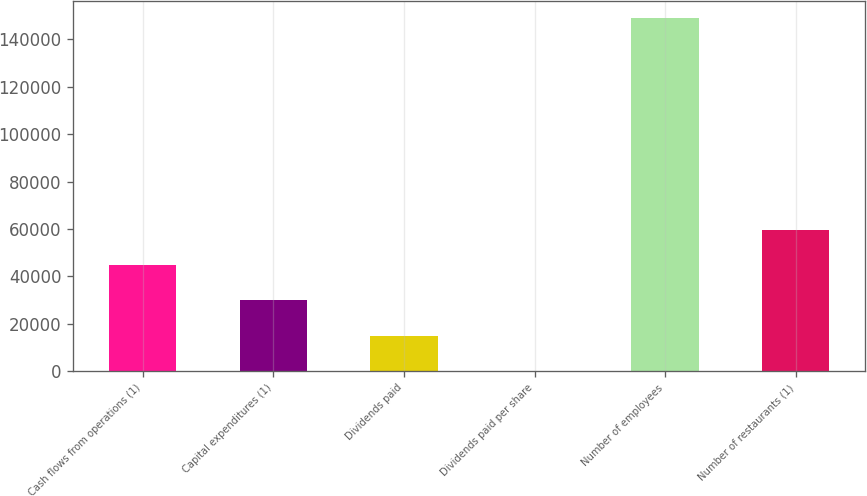Convert chart to OTSL. <chart><loc_0><loc_0><loc_500><loc_500><bar_chart><fcel>Cash flows from operations (1)<fcel>Capital expenditures (1)<fcel>Dividends paid<fcel>Dividends paid per share<fcel>Number of employees<fcel>Number of restaurants (1)<nl><fcel>44669.1<fcel>29780.2<fcel>14891.2<fcel>2.2<fcel>148892<fcel>59558.1<nl></chart> 